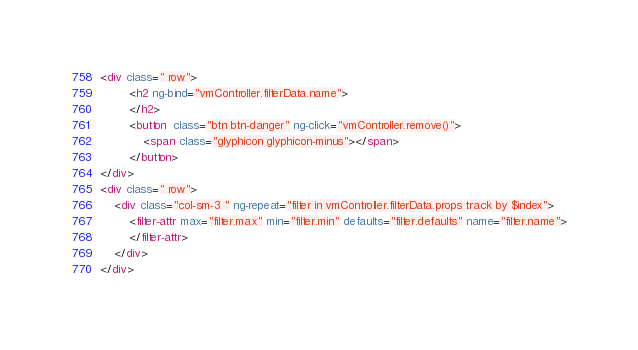Convert code to text. <code><loc_0><loc_0><loc_500><loc_500><_HTML_><div class=" row">
        <h2 ng-bind="vmController.filterData.name">
        </h2>
        <button  class="btn btn-danger" ng-click="vmController.remove()">
            <span class="glyphicon glyphicon-minus"></span>
        </button>
</div>
<div class=" row">
    <div class="col-sm-3 " ng-repeat="filter in vmController.filterData.props track by $index">
        <filter-attr max="filter.max" min="filter.min" defaults="filter.defaults" name="filter.name">
        </filter-attr>
    </div>
</div></code> 